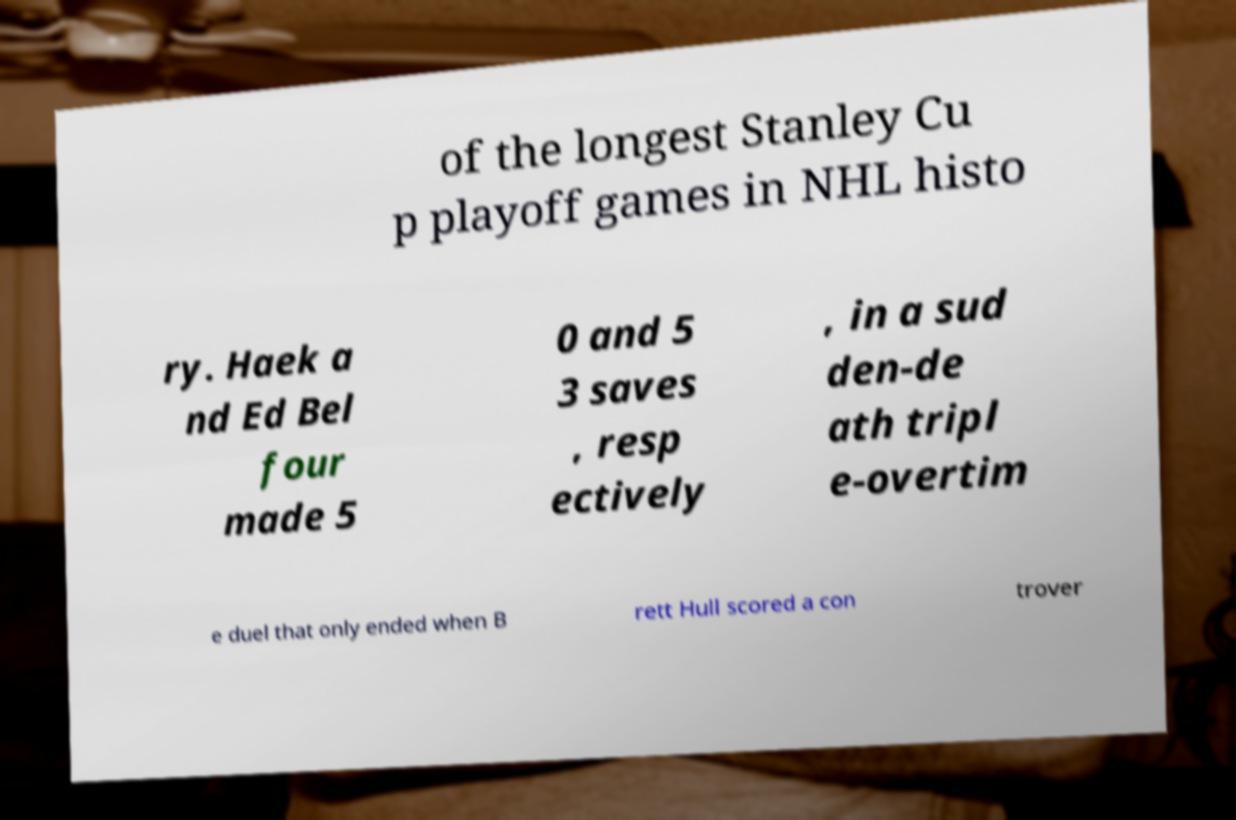Can you read and provide the text displayed in the image?This photo seems to have some interesting text. Can you extract and type it out for me? of the longest Stanley Cu p playoff games in NHL histo ry. Haek a nd Ed Bel four made 5 0 and 5 3 saves , resp ectively , in a sud den-de ath tripl e-overtim e duel that only ended when B rett Hull scored a con trover 